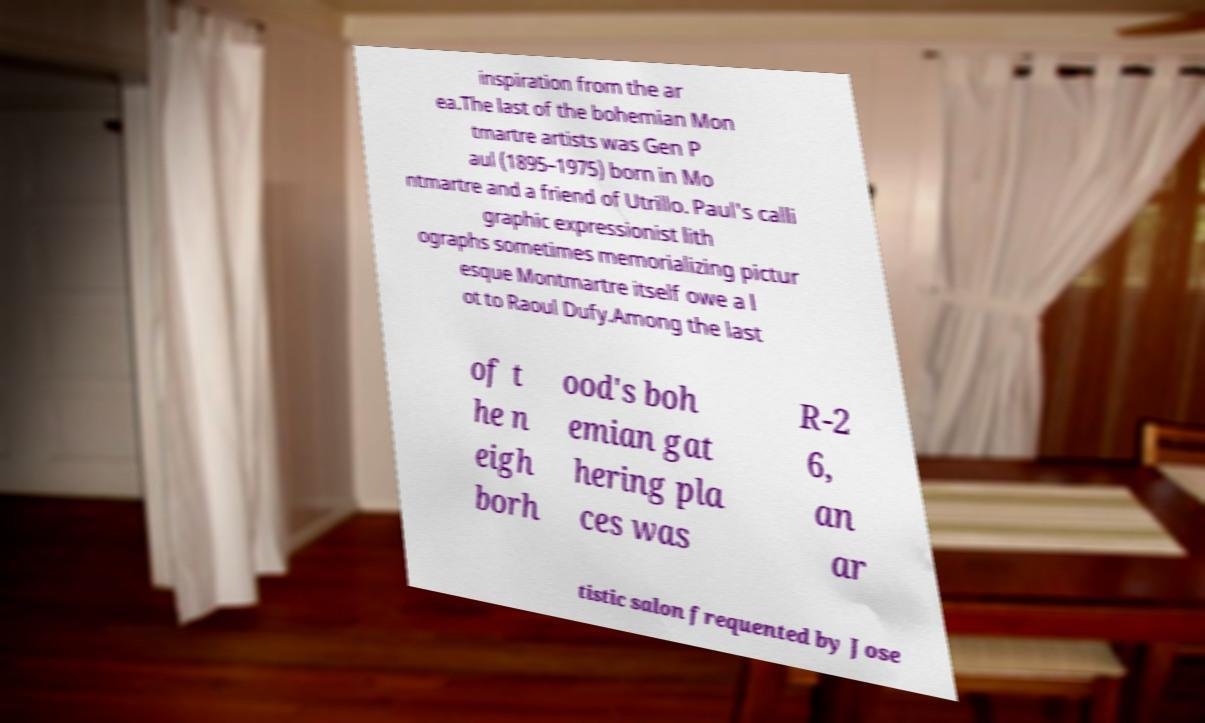Could you extract and type out the text from this image? inspiration from the ar ea.The last of the bohemian Mon tmartre artists was Gen P aul (1895–1975) born in Mo ntmartre and a friend of Utrillo. Paul's calli graphic expressionist lith ographs sometimes memorializing pictur esque Montmartre itself owe a l ot to Raoul Dufy.Among the last of t he n eigh borh ood's boh emian gat hering pla ces was R-2 6, an ar tistic salon frequented by Jose 